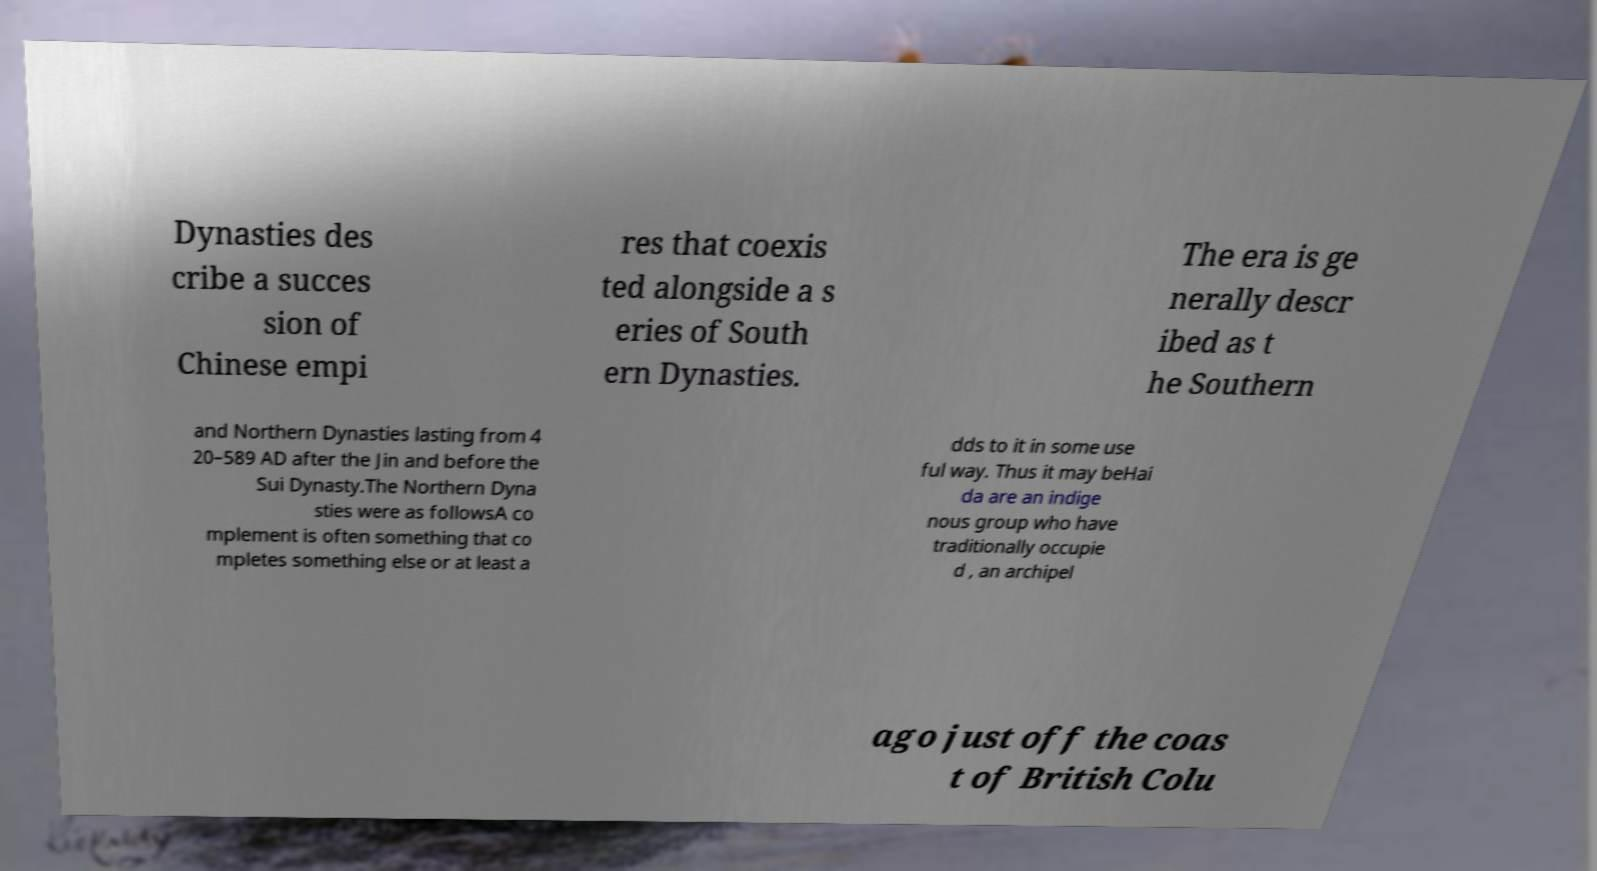Can you read and provide the text displayed in the image?This photo seems to have some interesting text. Can you extract and type it out for me? Dynasties des cribe a succes sion of Chinese empi res that coexis ted alongside a s eries of South ern Dynasties. The era is ge nerally descr ibed as t he Southern and Northern Dynasties lasting from 4 20–589 AD after the Jin and before the Sui Dynasty.The Northern Dyna sties were as followsA co mplement is often something that co mpletes something else or at least a dds to it in some use ful way. Thus it may beHai da are an indige nous group who have traditionally occupie d , an archipel ago just off the coas t of British Colu 